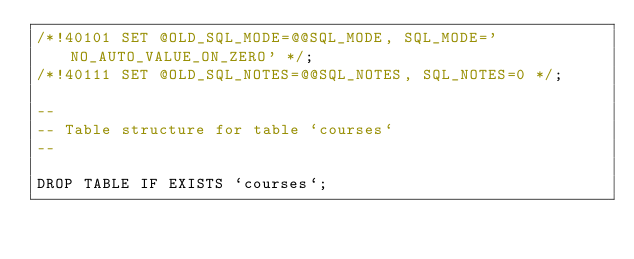Convert code to text. <code><loc_0><loc_0><loc_500><loc_500><_SQL_>/*!40101 SET @OLD_SQL_MODE=@@SQL_MODE, SQL_MODE='NO_AUTO_VALUE_ON_ZERO' */;
/*!40111 SET @OLD_SQL_NOTES=@@SQL_NOTES, SQL_NOTES=0 */;

--
-- Table structure for table `courses`
--

DROP TABLE IF EXISTS `courses`;</code> 